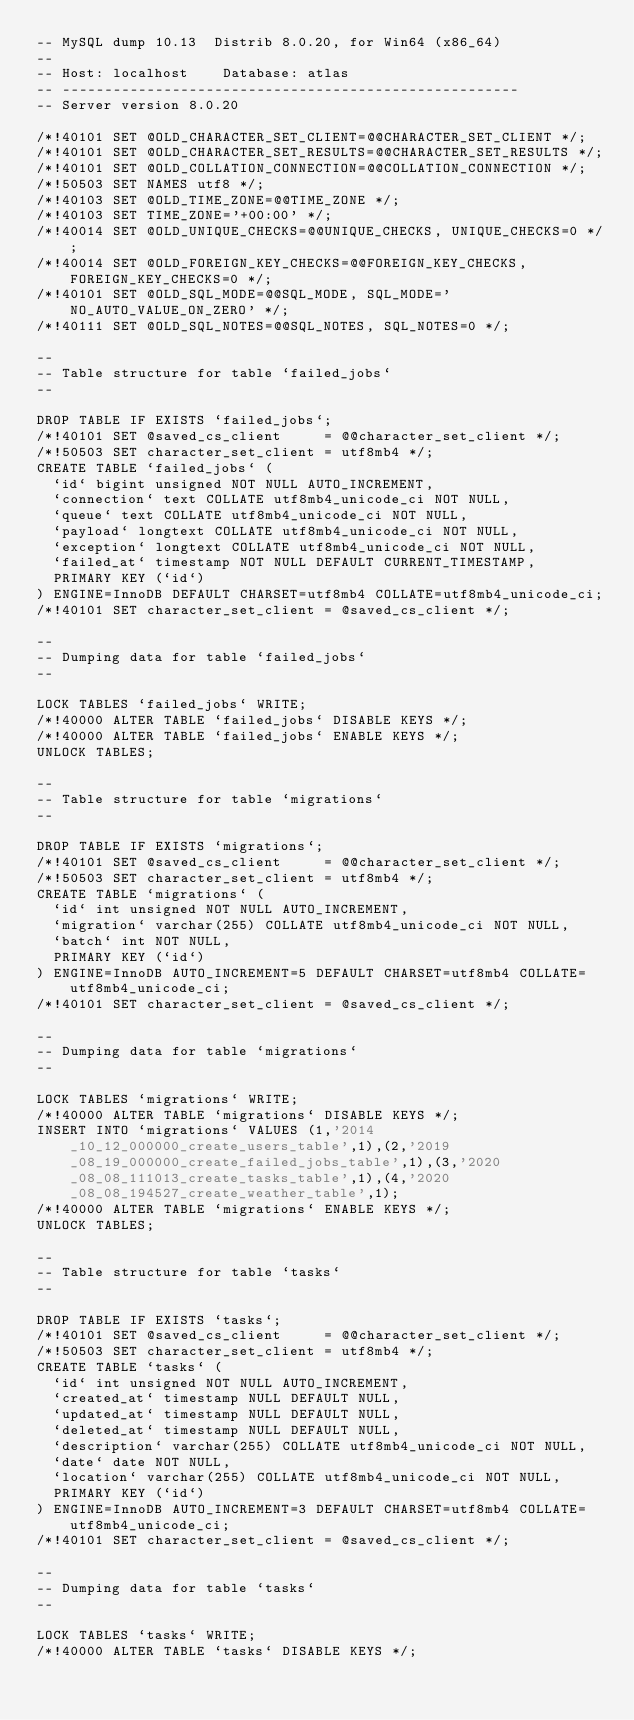<code> <loc_0><loc_0><loc_500><loc_500><_SQL_>-- MySQL dump 10.13  Distrib 8.0.20, for Win64 (x86_64)
--
-- Host: localhost    Database: atlas
-- ------------------------------------------------------
-- Server version	8.0.20

/*!40101 SET @OLD_CHARACTER_SET_CLIENT=@@CHARACTER_SET_CLIENT */;
/*!40101 SET @OLD_CHARACTER_SET_RESULTS=@@CHARACTER_SET_RESULTS */;
/*!40101 SET @OLD_COLLATION_CONNECTION=@@COLLATION_CONNECTION */;
/*!50503 SET NAMES utf8 */;
/*!40103 SET @OLD_TIME_ZONE=@@TIME_ZONE */;
/*!40103 SET TIME_ZONE='+00:00' */;
/*!40014 SET @OLD_UNIQUE_CHECKS=@@UNIQUE_CHECKS, UNIQUE_CHECKS=0 */;
/*!40014 SET @OLD_FOREIGN_KEY_CHECKS=@@FOREIGN_KEY_CHECKS, FOREIGN_KEY_CHECKS=0 */;
/*!40101 SET @OLD_SQL_MODE=@@SQL_MODE, SQL_MODE='NO_AUTO_VALUE_ON_ZERO' */;
/*!40111 SET @OLD_SQL_NOTES=@@SQL_NOTES, SQL_NOTES=0 */;

--
-- Table structure for table `failed_jobs`
--

DROP TABLE IF EXISTS `failed_jobs`;
/*!40101 SET @saved_cs_client     = @@character_set_client */;
/*!50503 SET character_set_client = utf8mb4 */;
CREATE TABLE `failed_jobs` (
  `id` bigint unsigned NOT NULL AUTO_INCREMENT,
  `connection` text COLLATE utf8mb4_unicode_ci NOT NULL,
  `queue` text COLLATE utf8mb4_unicode_ci NOT NULL,
  `payload` longtext COLLATE utf8mb4_unicode_ci NOT NULL,
  `exception` longtext COLLATE utf8mb4_unicode_ci NOT NULL,
  `failed_at` timestamp NOT NULL DEFAULT CURRENT_TIMESTAMP,
  PRIMARY KEY (`id`)
) ENGINE=InnoDB DEFAULT CHARSET=utf8mb4 COLLATE=utf8mb4_unicode_ci;
/*!40101 SET character_set_client = @saved_cs_client */;

--
-- Dumping data for table `failed_jobs`
--

LOCK TABLES `failed_jobs` WRITE;
/*!40000 ALTER TABLE `failed_jobs` DISABLE KEYS */;
/*!40000 ALTER TABLE `failed_jobs` ENABLE KEYS */;
UNLOCK TABLES;

--
-- Table structure for table `migrations`
--

DROP TABLE IF EXISTS `migrations`;
/*!40101 SET @saved_cs_client     = @@character_set_client */;
/*!50503 SET character_set_client = utf8mb4 */;
CREATE TABLE `migrations` (
  `id` int unsigned NOT NULL AUTO_INCREMENT,
  `migration` varchar(255) COLLATE utf8mb4_unicode_ci NOT NULL,
  `batch` int NOT NULL,
  PRIMARY KEY (`id`)
) ENGINE=InnoDB AUTO_INCREMENT=5 DEFAULT CHARSET=utf8mb4 COLLATE=utf8mb4_unicode_ci;
/*!40101 SET character_set_client = @saved_cs_client */;

--
-- Dumping data for table `migrations`
--

LOCK TABLES `migrations` WRITE;
/*!40000 ALTER TABLE `migrations` DISABLE KEYS */;
INSERT INTO `migrations` VALUES (1,'2014_10_12_000000_create_users_table',1),(2,'2019_08_19_000000_create_failed_jobs_table',1),(3,'2020_08_08_111013_create_tasks_table',1),(4,'2020_08_08_194527_create_weather_table',1);
/*!40000 ALTER TABLE `migrations` ENABLE KEYS */;
UNLOCK TABLES;

--
-- Table structure for table `tasks`
--

DROP TABLE IF EXISTS `tasks`;
/*!40101 SET @saved_cs_client     = @@character_set_client */;
/*!50503 SET character_set_client = utf8mb4 */;
CREATE TABLE `tasks` (
  `id` int unsigned NOT NULL AUTO_INCREMENT,
  `created_at` timestamp NULL DEFAULT NULL,
  `updated_at` timestamp NULL DEFAULT NULL,
  `deleted_at` timestamp NULL DEFAULT NULL,
  `description` varchar(255) COLLATE utf8mb4_unicode_ci NOT NULL,
  `date` date NOT NULL,
  `location` varchar(255) COLLATE utf8mb4_unicode_ci NOT NULL,
  PRIMARY KEY (`id`)
) ENGINE=InnoDB AUTO_INCREMENT=3 DEFAULT CHARSET=utf8mb4 COLLATE=utf8mb4_unicode_ci;
/*!40101 SET character_set_client = @saved_cs_client */;

--
-- Dumping data for table `tasks`
--

LOCK TABLES `tasks` WRITE;
/*!40000 ALTER TABLE `tasks` DISABLE KEYS */;</code> 